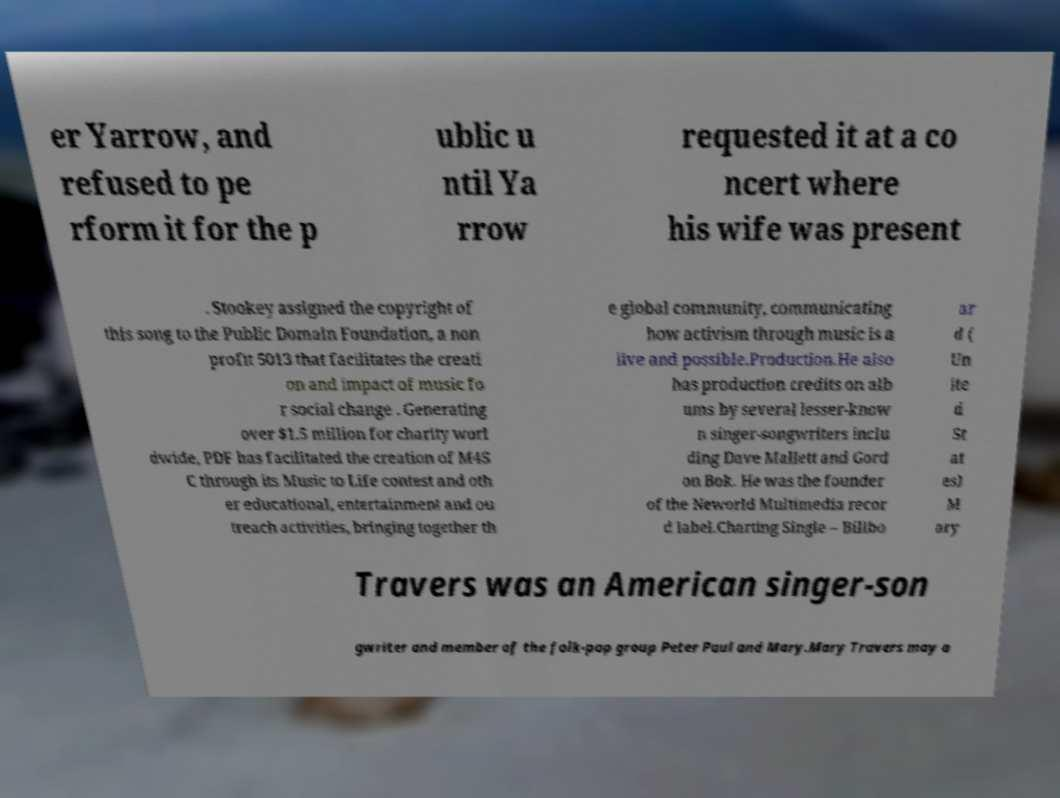What messages or text are displayed in this image? I need them in a readable, typed format. er Yarrow, and refused to pe rform it for the p ublic u ntil Ya rrow requested it at a co ncert where his wife was present . Stookey assigned the copyright of this song to the Public Domain Foundation, a non profit 5013 that facilitates the creati on and impact of music fo r social change . Generating over $1.5 million for charity worl dwide, PDF has facilitated the creation of M4S C through its Music to Life contest and oth er educational, entertainment and ou treach activities, bringing together th e global community, communicating how activism through music is a live and possible.Production.He also has production credits on alb ums by several lesser-know n singer-songwriters inclu ding Dave Mallett and Gord on Bok. He was the founder of the Neworld Multimedia recor d label.Charting Single – Billbo ar d ( Un ite d St at es) M ary Travers was an American singer-son gwriter and member of the folk-pop group Peter Paul and Mary.Mary Travers may a 